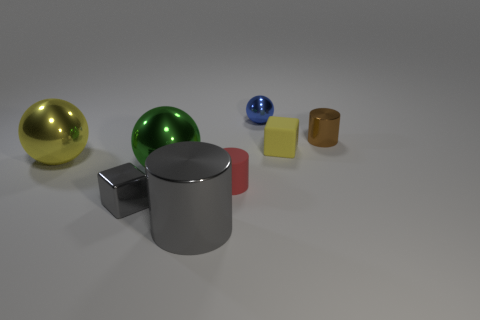Subtract all large balls. How many balls are left? 1 Add 2 gray metal cylinders. How many objects exist? 10 Subtract 1 balls. How many balls are left? 2 Subtract all blocks. How many objects are left? 6 Subtract all purple spheres. Subtract all cyan cylinders. How many spheres are left? 3 Add 3 small brown objects. How many small brown objects exist? 4 Subtract 1 gray blocks. How many objects are left? 7 Subtract all purple cubes. Subtract all large metallic objects. How many objects are left? 5 Add 7 green shiny balls. How many green shiny balls are left? 8 